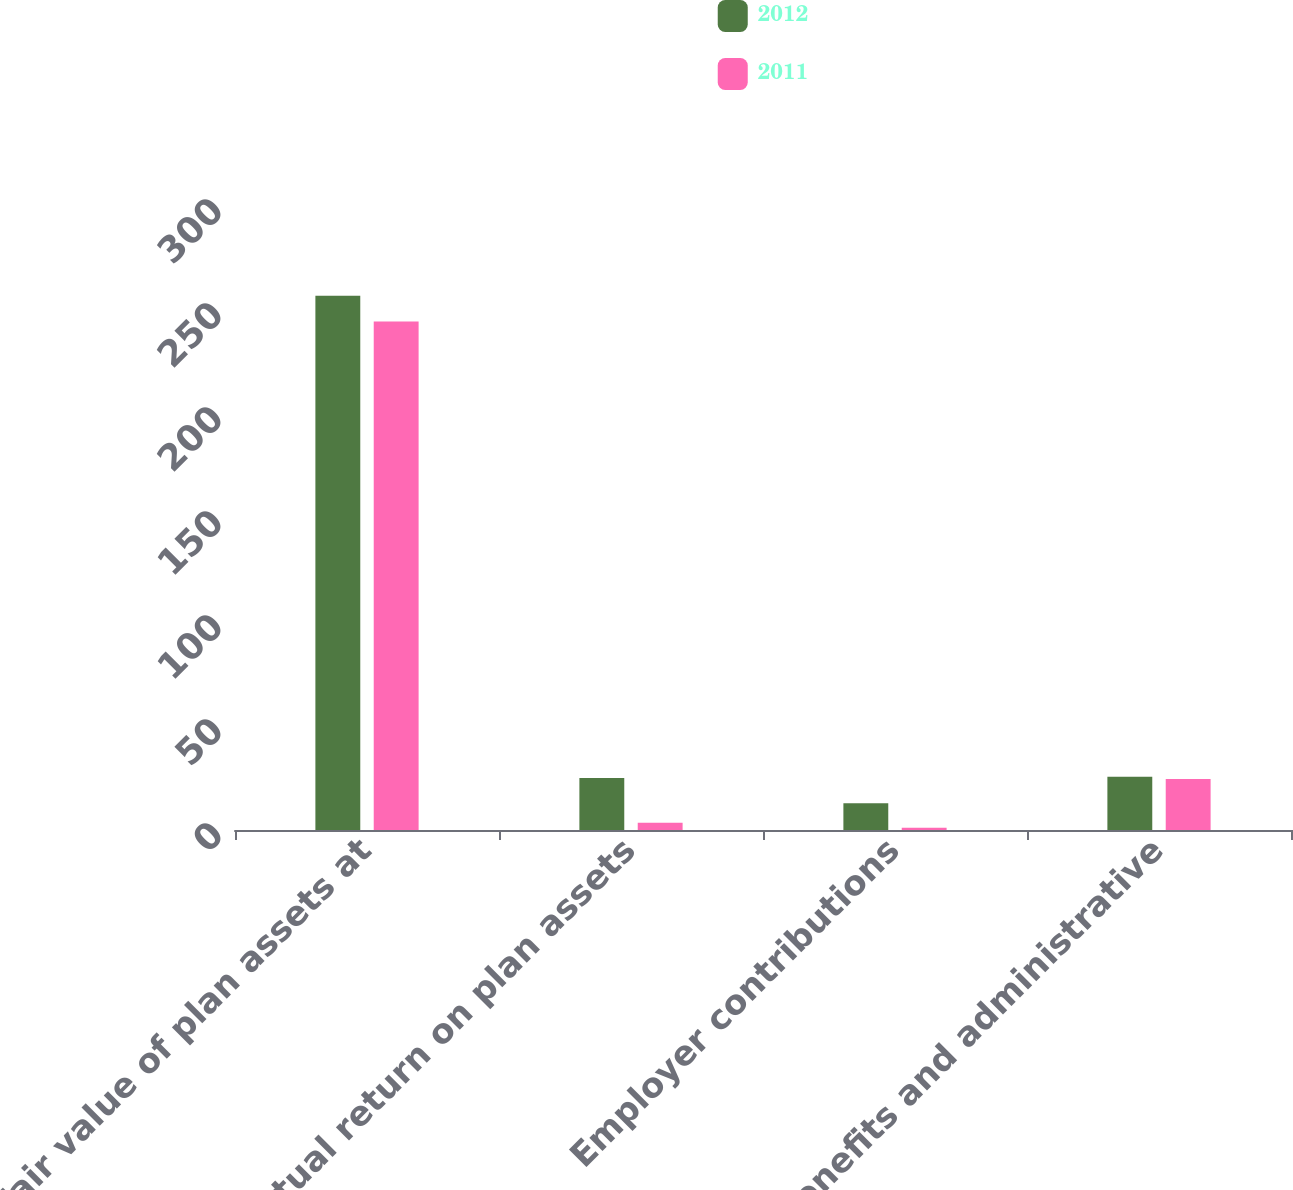Convert chart to OTSL. <chart><loc_0><loc_0><loc_500><loc_500><stacked_bar_chart><ecel><fcel>Fair value of plan assets at<fcel>Actual return on plan assets<fcel>Employer contributions<fcel>Benefits and administrative<nl><fcel>2012<fcel>256.8<fcel>25<fcel>12.9<fcel>25.6<nl><fcel>2011<fcel>244.5<fcel>3.5<fcel>1.1<fcel>24.5<nl></chart> 